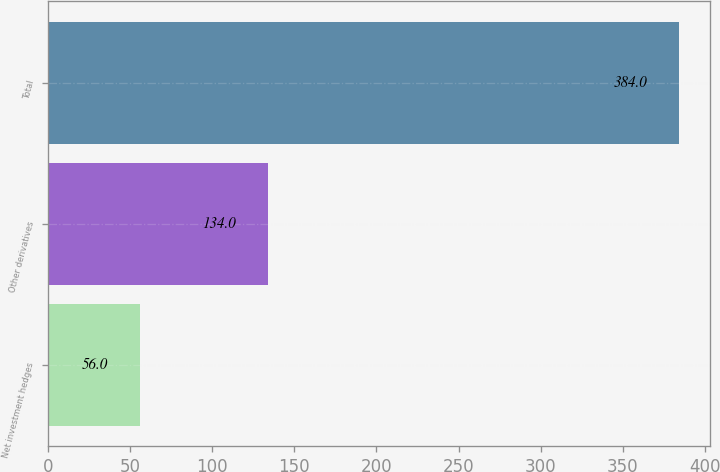Convert chart. <chart><loc_0><loc_0><loc_500><loc_500><bar_chart><fcel>Net investment hedges<fcel>Other derivatives<fcel>Total<nl><fcel>56<fcel>134<fcel>384<nl></chart> 